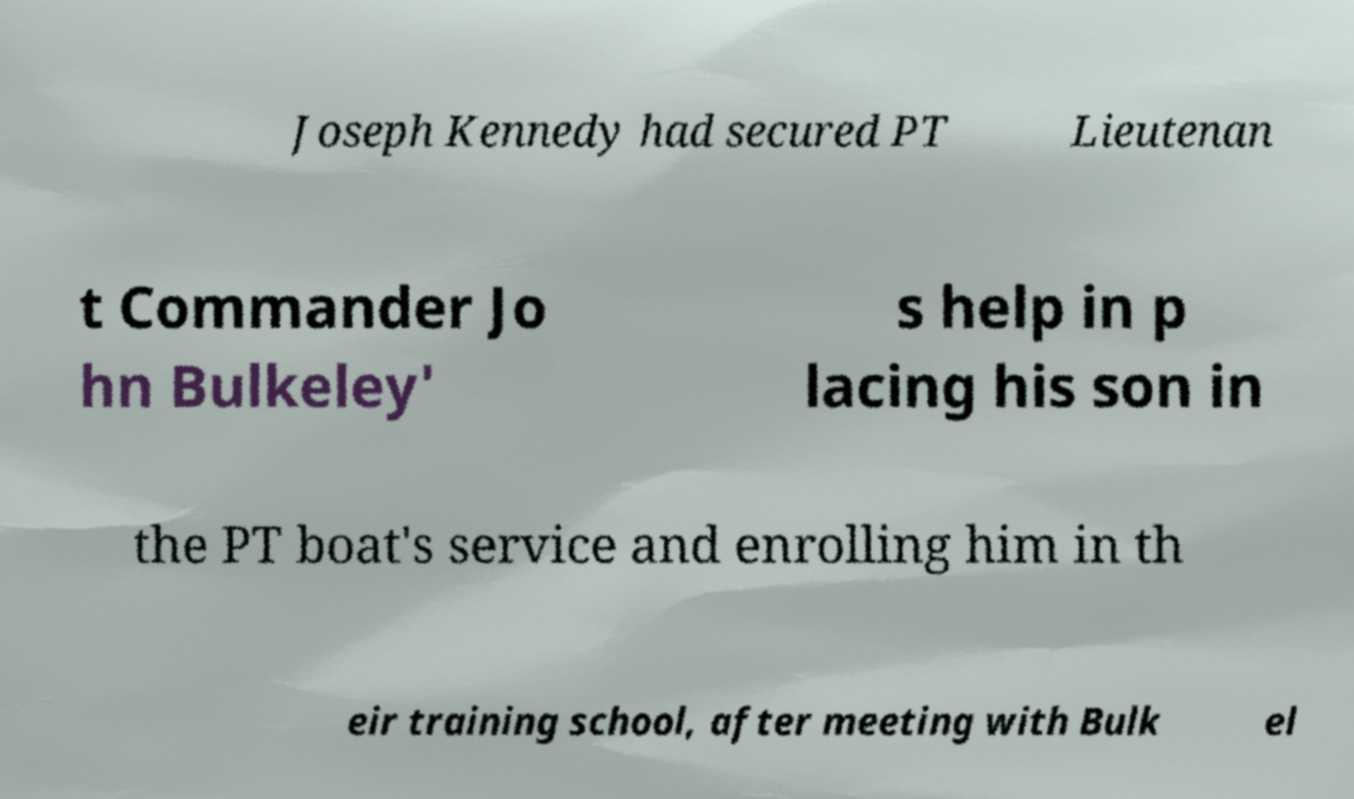What messages or text are displayed in this image? I need them in a readable, typed format. Joseph Kennedy had secured PT Lieutenan t Commander Jo hn Bulkeley' s help in p lacing his son in the PT boat's service and enrolling him in th eir training school, after meeting with Bulk el 